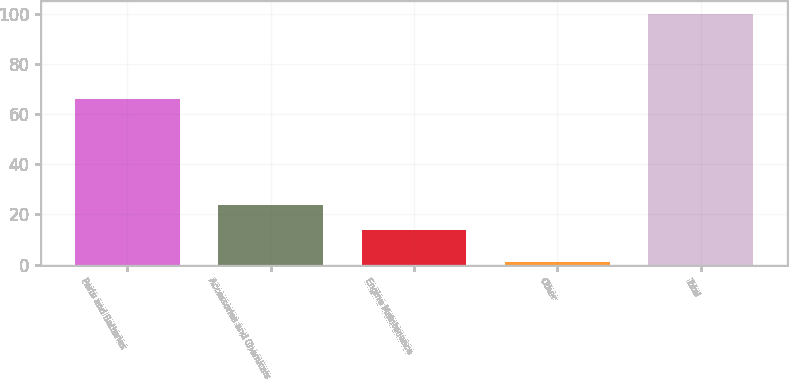Convert chart. <chart><loc_0><loc_0><loc_500><loc_500><bar_chart><fcel>Parts and Batteries<fcel>Accessories and Chemicals<fcel>Engine Maintenance<fcel>Other<fcel>Total<nl><fcel>66<fcel>23.9<fcel>14<fcel>1<fcel>100<nl></chart> 